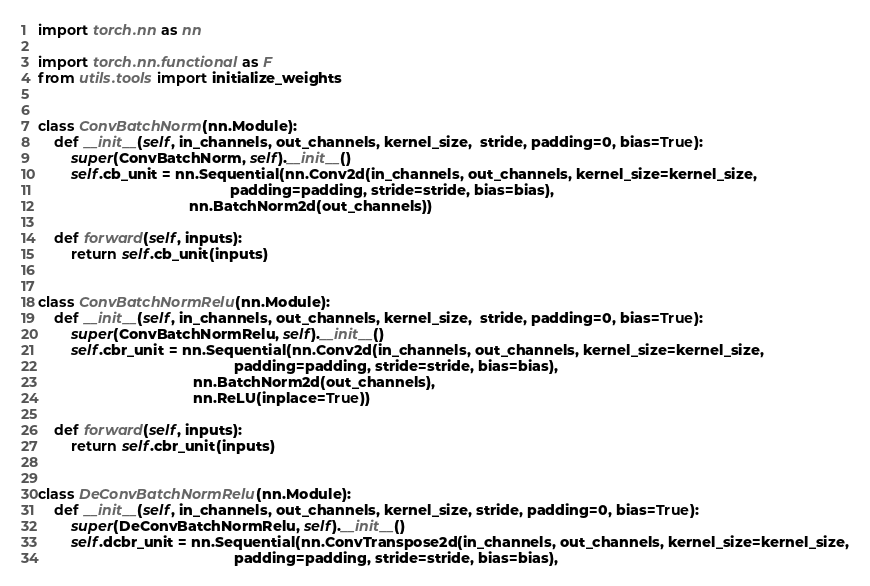Convert code to text. <code><loc_0><loc_0><loc_500><loc_500><_Python_>import torch.nn as nn

import torch.nn.functional as F
from utils.tools import initialize_weights


class ConvBatchNorm(nn.Module):
    def __init__(self, in_channels, out_channels, kernel_size,  stride, padding=0, bias=True):
        super(ConvBatchNorm, self).__init__()
        self.cb_unit = nn.Sequential(nn.Conv2d(in_channels, out_channels, kernel_size=kernel_size,
                                               padding=padding, stride=stride, bias=bias),
                                     nn.BatchNorm2d(out_channels))
        
    def forward(self, inputs):        
        return self.cb_unit(inputs)


class ConvBatchNormRelu(nn.Module):
    def __init__(self, in_channels, out_channels, kernel_size,  stride, padding=0, bias=True):
        super(ConvBatchNormRelu, self).__init__()
        self.cbr_unit = nn.Sequential(nn.Conv2d(in_channels, out_channels, kernel_size=kernel_size,
                                                padding=padding, stride=stride, bias=bias),
                                      nn.BatchNorm2d(out_channels),
                                      nn.ReLU(inplace=True))

    def forward(self, inputs):
        return self.cbr_unit(inputs)
    
    
class DeConvBatchNormRelu(nn.Module):
    def __init__(self, in_channels, out_channels, kernel_size, stride, padding=0, bias=True):
        super(DeConvBatchNormRelu, self).__init__()
        self.dcbr_unit = nn.Sequential(nn.ConvTranspose2d(in_channels, out_channels, kernel_size=kernel_size,
                                                padding=padding, stride=stride, bias=bias),</code> 